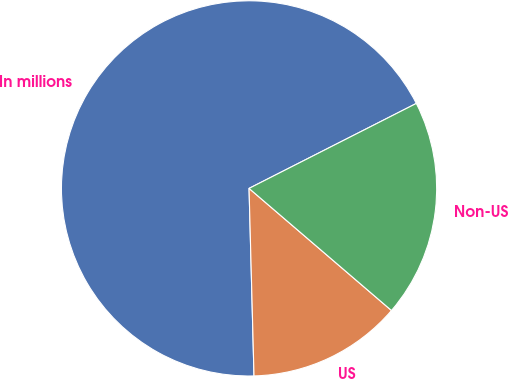Convert chart. <chart><loc_0><loc_0><loc_500><loc_500><pie_chart><fcel>In millions<fcel>US<fcel>Non-US<nl><fcel>67.94%<fcel>13.3%<fcel>18.76%<nl></chart> 